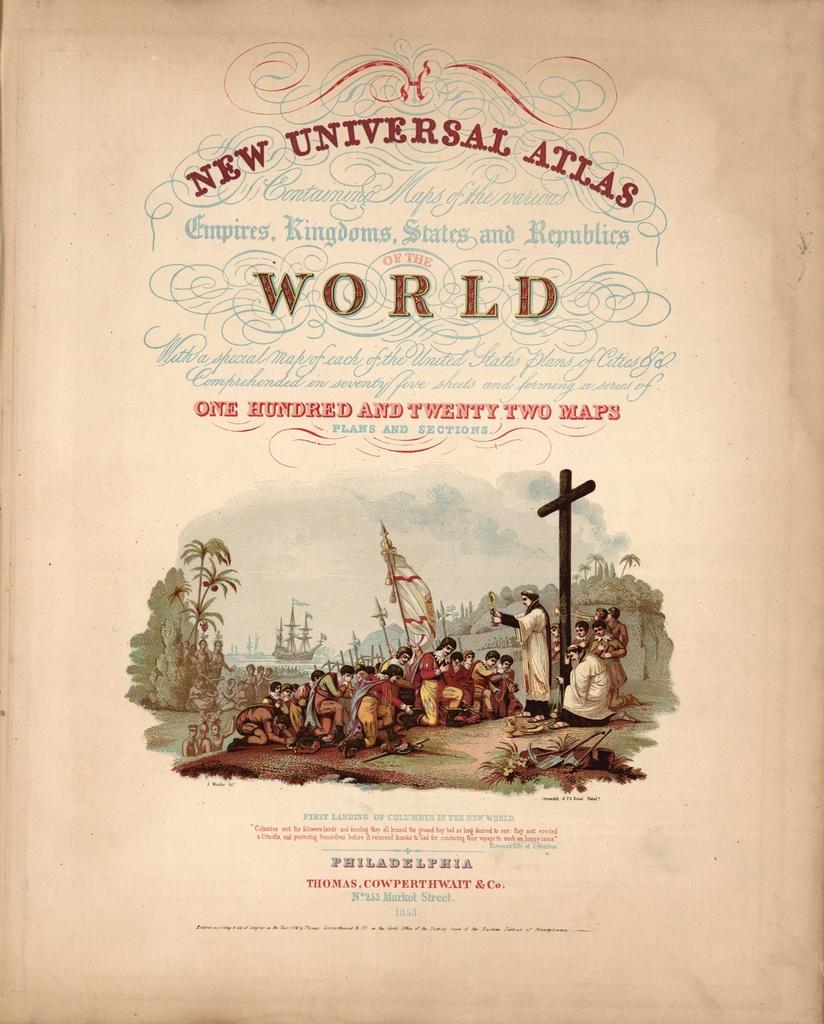This is a universal atlas of what?
Your response must be concise. The world. How many maps are there?
Offer a very short reply. One hundred and twenty two. 